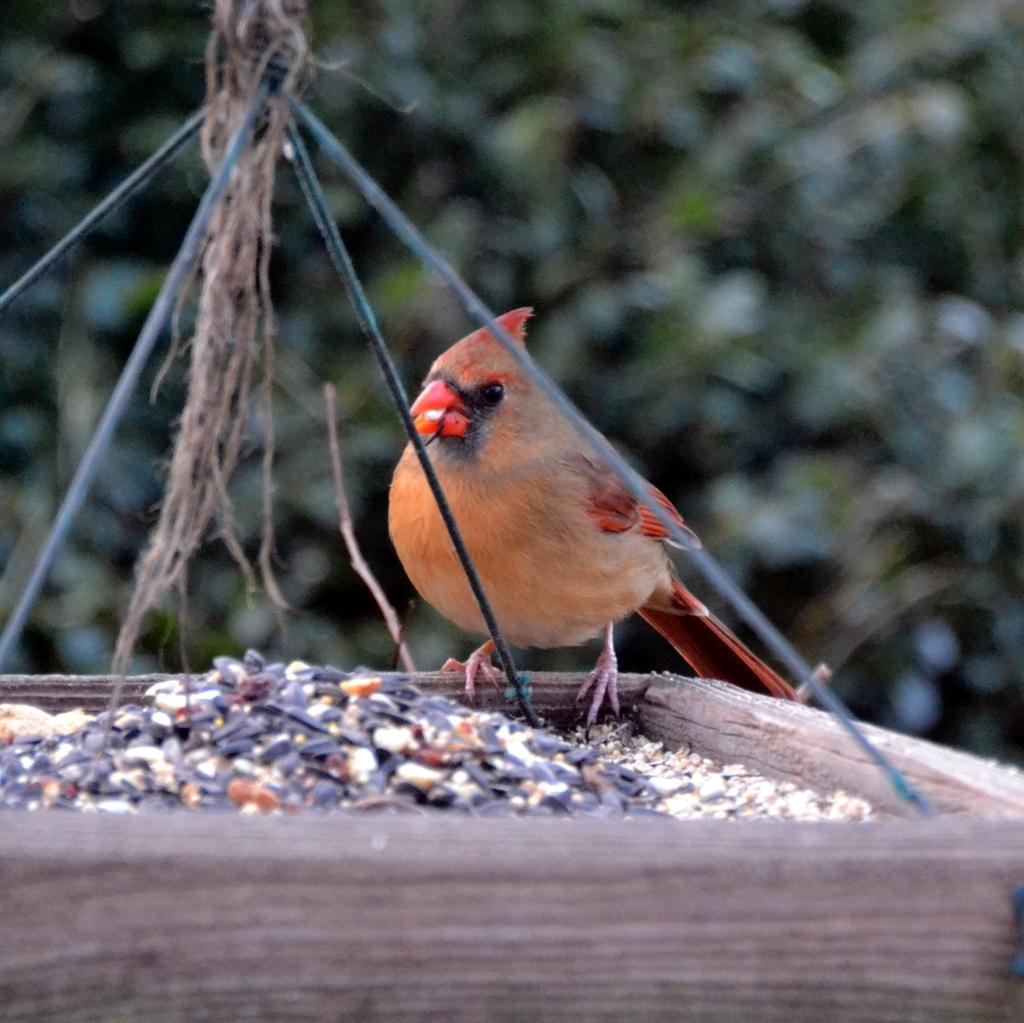What is the main subject in the foreground of the picture? There is a wooden object in the foreground of the picture. What can be observed about the wooden object? The wooden object contains grains. What animal is present on the wooden object? There is a bird on the wooden object. What type of environment is visible in the background of the picture? There is greenery in the background of the picture. What type of soap is being used to clean the bird in the image? There is no soap or cleaning activity depicted in the image; it features a bird on a wooden object with grains. Is there a camping site visible in the background of the image? There is no camping site or any indication of camping in the image; it features greenery in the background. 